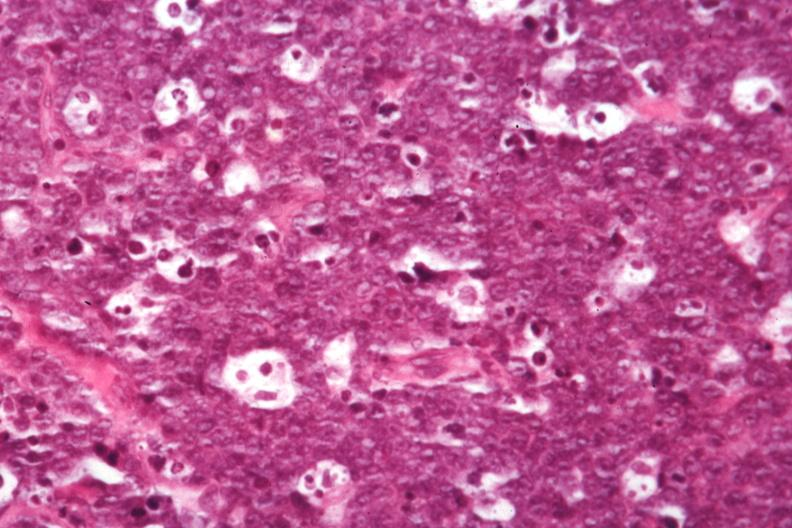what is present?
Answer the question using a single word or phrase. Burkitts lymphoma 